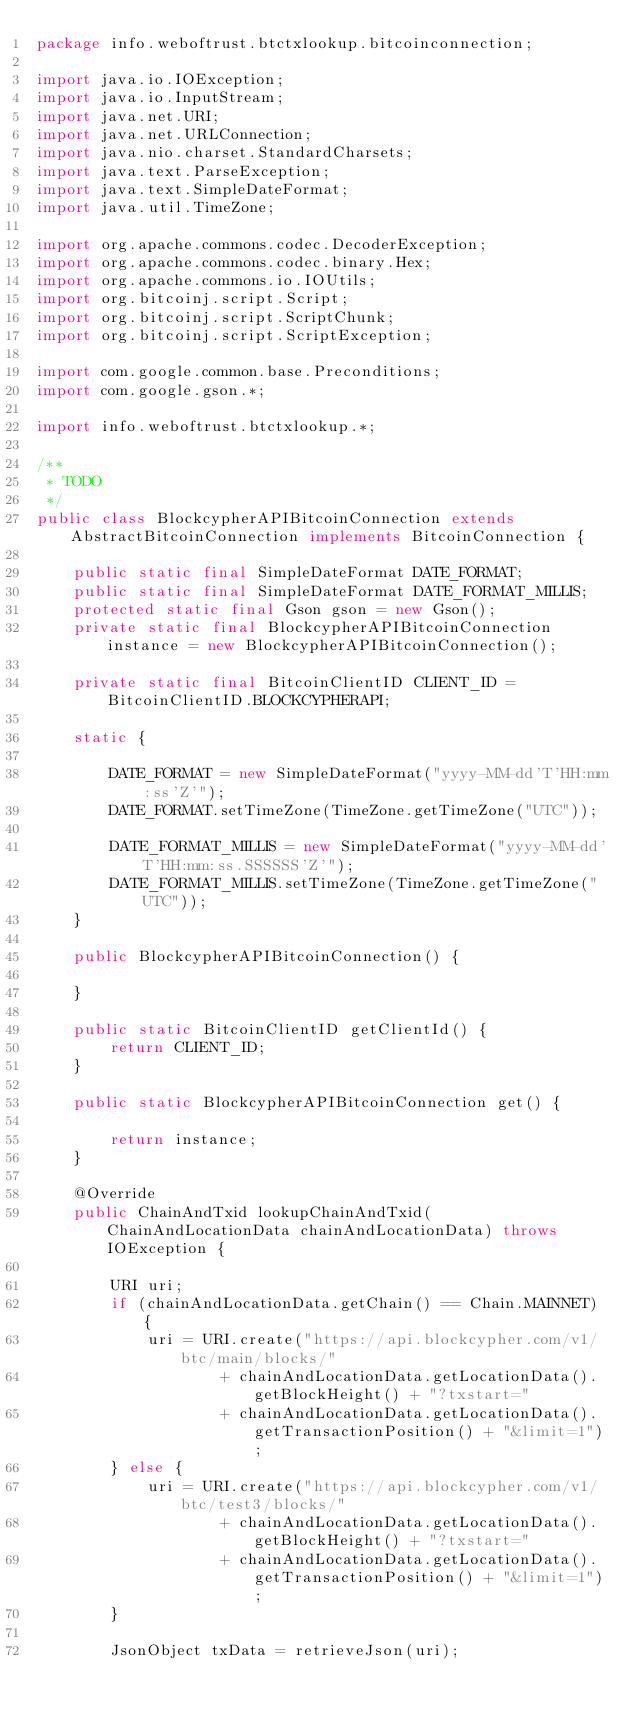<code> <loc_0><loc_0><loc_500><loc_500><_Java_>package info.weboftrust.btctxlookup.bitcoinconnection;

import java.io.IOException;
import java.io.InputStream;
import java.net.URI;
import java.net.URLConnection;
import java.nio.charset.StandardCharsets;
import java.text.ParseException;
import java.text.SimpleDateFormat;
import java.util.TimeZone;

import org.apache.commons.codec.DecoderException;
import org.apache.commons.codec.binary.Hex;
import org.apache.commons.io.IOUtils;
import org.bitcoinj.script.Script;
import org.bitcoinj.script.ScriptChunk;
import org.bitcoinj.script.ScriptException;

import com.google.common.base.Preconditions;
import com.google.gson.*;

import info.weboftrust.btctxlookup.*;

/**
 * TODO
 */
public class BlockcypherAPIBitcoinConnection extends AbstractBitcoinConnection implements BitcoinConnection {

	public static final SimpleDateFormat DATE_FORMAT;
	public static final SimpleDateFormat DATE_FORMAT_MILLIS;
	protected static final Gson gson = new Gson();
	private static final BlockcypherAPIBitcoinConnection instance = new BlockcypherAPIBitcoinConnection();

	private static final BitcoinClientID CLIENT_ID = BitcoinClientID.BLOCKCYPHERAPI;

	static {

		DATE_FORMAT = new SimpleDateFormat("yyyy-MM-dd'T'HH:mm:ss'Z'");
		DATE_FORMAT.setTimeZone(TimeZone.getTimeZone("UTC"));

		DATE_FORMAT_MILLIS = new SimpleDateFormat("yyyy-MM-dd'T'HH:mm:ss.SSSSSS'Z'");
		DATE_FORMAT_MILLIS.setTimeZone(TimeZone.getTimeZone("UTC"));
	}

	public BlockcypherAPIBitcoinConnection() {

	}

	public static BitcoinClientID getClientId() {
		return CLIENT_ID;
	}

	public static BlockcypherAPIBitcoinConnection get() {

		return instance;
	}

	@Override
	public ChainAndTxid lookupChainAndTxid(ChainAndLocationData chainAndLocationData) throws IOException {

		URI uri;
		if (chainAndLocationData.getChain() == Chain.MAINNET) {
			uri = URI.create("https://api.blockcypher.com/v1/btc/main/blocks/"
					+ chainAndLocationData.getLocationData().getBlockHeight() + "?txstart="
					+ chainAndLocationData.getLocationData().getTransactionPosition() + "&limit=1");
		} else {
			uri = URI.create("https://api.blockcypher.com/v1/btc/test3/blocks/"
					+ chainAndLocationData.getLocationData().getBlockHeight() + "?txstart="
					+ chainAndLocationData.getLocationData().getTransactionPosition() + "&limit=1");
		}

		JsonObject txData = retrieveJson(uri);</code> 